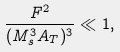<formula> <loc_0><loc_0><loc_500><loc_500>\frac { F ^ { 2 } } { ( M _ { s } ^ { 3 } A _ { T } ) ^ { 3 } } \ll 1 ,</formula> 